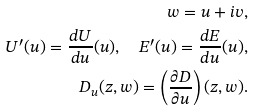<formula> <loc_0><loc_0><loc_500><loc_500>w = u + i v , \\ U ^ { \prime } ( u ) = \frac { d U } { d u } ( u ) , \quad E ^ { \prime } ( u ) = \frac { d E } { d u } ( u ) , \\ D _ { u } ( z , w ) = \left ( \frac { \partial D } { \partial u } \right ) ( z , w ) .</formula> 